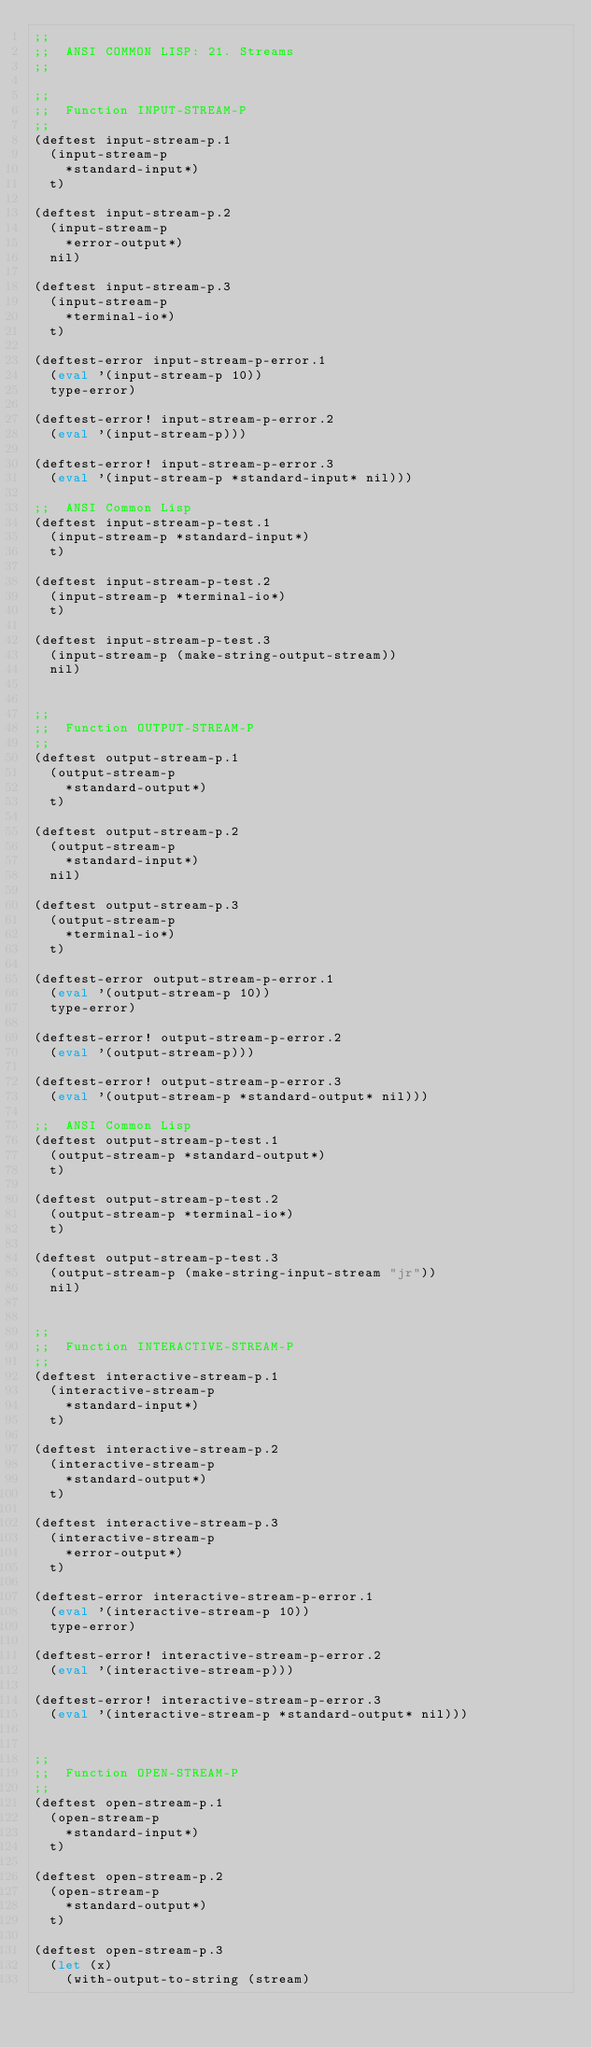<code> <loc_0><loc_0><loc_500><loc_500><_Lisp_>;;
;;  ANSI COMMON LISP: 21. Streams
;;

;;
;;  Function INPUT-STREAM-P
;;
(deftest input-stream-p.1
  (input-stream-p
    *standard-input*)
  t)

(deftest input-stream-p.2
  (input-stream-p
    *error-output*)
  nil)

(deftest input-stream-p.3
  (input-stream-p
    *terminal-io*)
  t)

(deftest-error input-stream-p-error.1
  (eval '(input-stream-p 10))
  type-error)

(deftest-error! input-stream-p-error.2
  (eval '(input-stream-p)))

(deftest-error! input-stream-p-error.3
  (eval '(input-stream-p *standard-input* nil)))

;;  ANSI Common Lisp
(deftest input-stream-p-test.1
  (input-stream-p *standard-input*)
  t)

(deftest input-stream-p-test.2
  (input-stream-p *terminal-io*)
  t)

(deftest input-stream-p-test.3
  (input-stream-p (make-string-output-stream))
  nil)


;;
;;  Function OUTPUT-STREAM-P
;;
(deftest output-stream-p.1
  (output-stream-p
    *standard-output*)
  t)

(deftest output-stream-p.2
  (output-stream-p
    *standard-input*)
  nil)

(deftest output-stream-p.3
  (output-stream-p
    *terminal-io*)
  t)

(deftest-error output-stream-p-error.1
  (eval '(output-stream-p 10))
  type-error)

(deftest-error! output-stream-p-error.2
  (eval '(output-stream-p)))

(deftest-error! output-stream-p-error.3
  (eval '(output-stream-p *standard-output* nil)))

;;  ANSI Common Lisp
(deftest output-stream-p-test.1
  (output-stream-p *standard-output*)
  t)

(deftest output-stream-p-test.2
  (output-stream-p *terminal-io*)
  t)

(deftest output-stream-p-test.3
  (output-stream-p (make-string-input-stream "jr"))
  nil)


;;
;;  Function INTERACTIVE-STREAM-P
;;
(deftest interactive-stream-p.1
  (interactive-stream-p
    *standard-input*)
  t)

(deftest interactive-stream-p.2
  (interactive-stream-p
    *standard-output*)
  t)

(deftest interactive-stream-p.3
  (interactive-stream-p
    *error-output*)
  t)

(deftest-error interactive-stream-p-error.1
  (eval '(interactive-stream-p 10))
  type-error)

(deftest-error! interactive-stream-p-error.2
  (eval '(interactive-stream-p)))

(deftest-error! interactive-stream-p-error.3
  (eval '(interactive-stream-p *standard-output* nil)))


;;
;;  Function OPEN-STREAM-P
;;
(deftest open-stream-p.1
  (open-stream-p
    *standard-input*)
  t)

(deftest open-stream-p.2
  (open-stream-p
    *standard-output*)
  t)

(deftest open-stream-p.3
  (let (x)
    (with-output-to-string (stream)</code> 